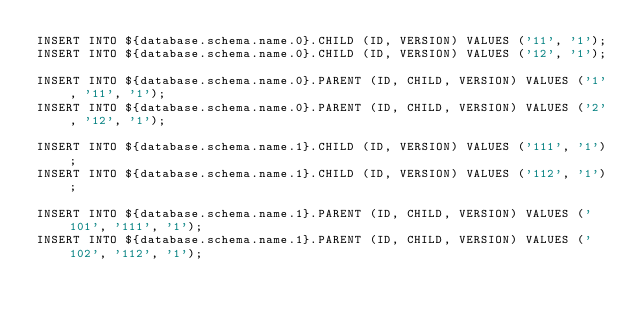<code> <loc_0><loc_0><loc_500><loc_500><_SQL_>INSERT INTO ${database.schema.name.0}.CHILD (ID, VERSION) VALUES ('11', '1');
INSERT INTO ${database.schema.name.0}.CHILD (ID, VERSION) VALUES ('12', '1');

INSERT INTO ${database.schema.name.0}.PARENT (ID, CHILD, VERSION) VALUES ('1', '11', '1');
INSERT INTO ${database.schema.name.0}.PARENT (ID, CHILD, VERSION) VALUES ('2', '12', '1');

INSERT INTO ${database.schema.name.1}.CHILD (ID, VERSION) VALUES ('111', '1');
INSERT INTO ${database.schema.name.1}.CHILD (ID, VERSION) VALUES ('112', '1');

INSERT INTO ${database.schema.name.1}.PARENT (ID, CHILD, VERSION) VALUES ('101', '111', '1');
INSERT INTO ${database.schema.name.1}.PARENT (ID, CHILD, VERSION) VALUES ('102', '112', '1');
</code> 